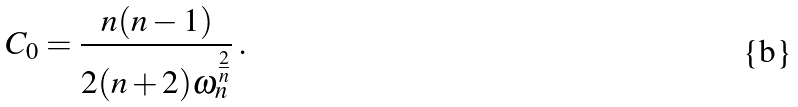<formula> <loc_0><loc_0><loc_500><loc_500>C _ { 0 } = \frac { n ( n - 1 ) } { 2 ( n + 2 ) \omega _ { n } ^ { \frac { 2 } { n } } } \, .</formula> 